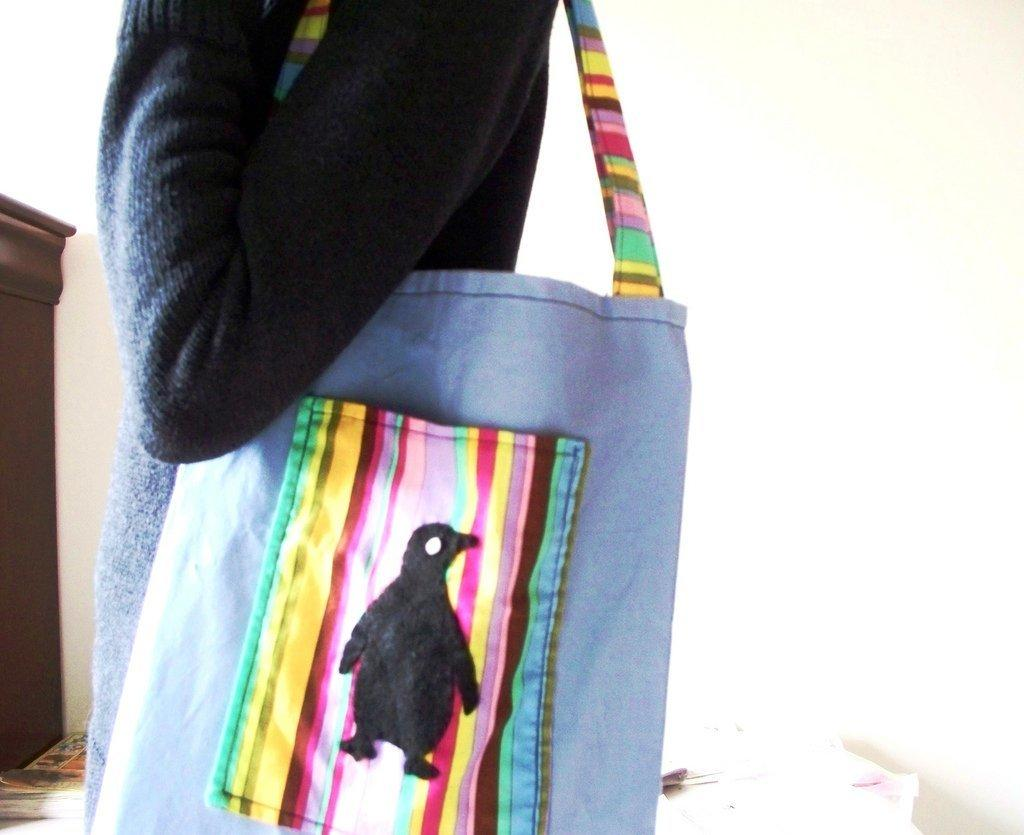What is the main subject of the image? There is a person in the image. What is the person doing in the image? The person is standing. What is the person holding in the image? The person is holding a bag. Can you describe the bag in more detail? The bag has a pocket, and there is a penguin drawn on the pocket. What is the texture of the sink in the image? There is no sink present in the image. Who is the representative of the penguin in the image? The image does not depict a penguin as a separate entity or character; it is simply a drawing on the pocket of the bag. 